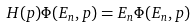<formula> <loc_0><loc_0><loc_500><loc_500>H ( p ) \Phi ( E _ { n } , p ) = E _ { n } \Phi ( E _ { n } , p )</formula> 